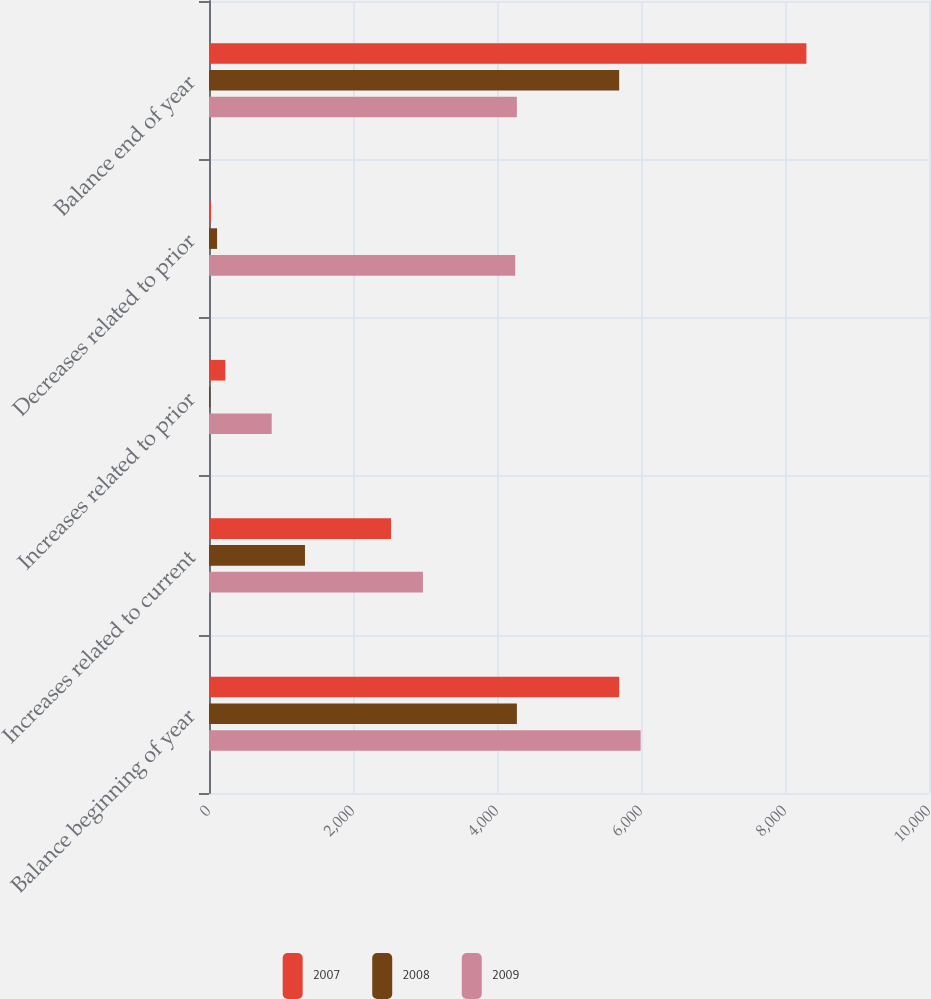<chart> <loc_0><loc_0><loc_500><loc_500><stacked_bar_chart><ecel><fcel>Balance beginning of year<fcel>Increases related to current<fcel>Increases related to prior<fcel>Decreases related to prior<fcel>Balance end of year<nl><fcel>2007<fcel>5697<fcel>2528<fcel>227<fcel>29<fcel>8297<nl><fcel>2008<fcel>4276<fcel>1333<fcel>19<fcel>112<fcel>5697<nl><fcel>2009<fcel>5995<fcel>2971<fcel>871<fcel>4253<fcel>4276<nl></chart> 